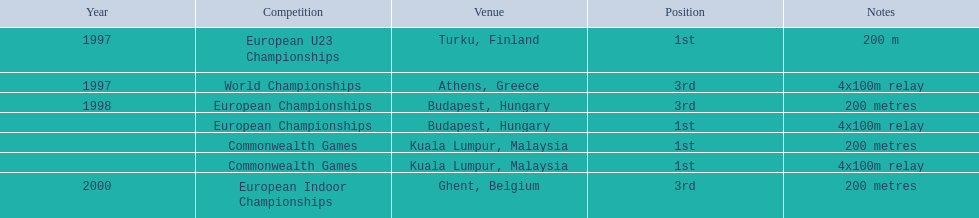How many overall years did golding participate? 3. 